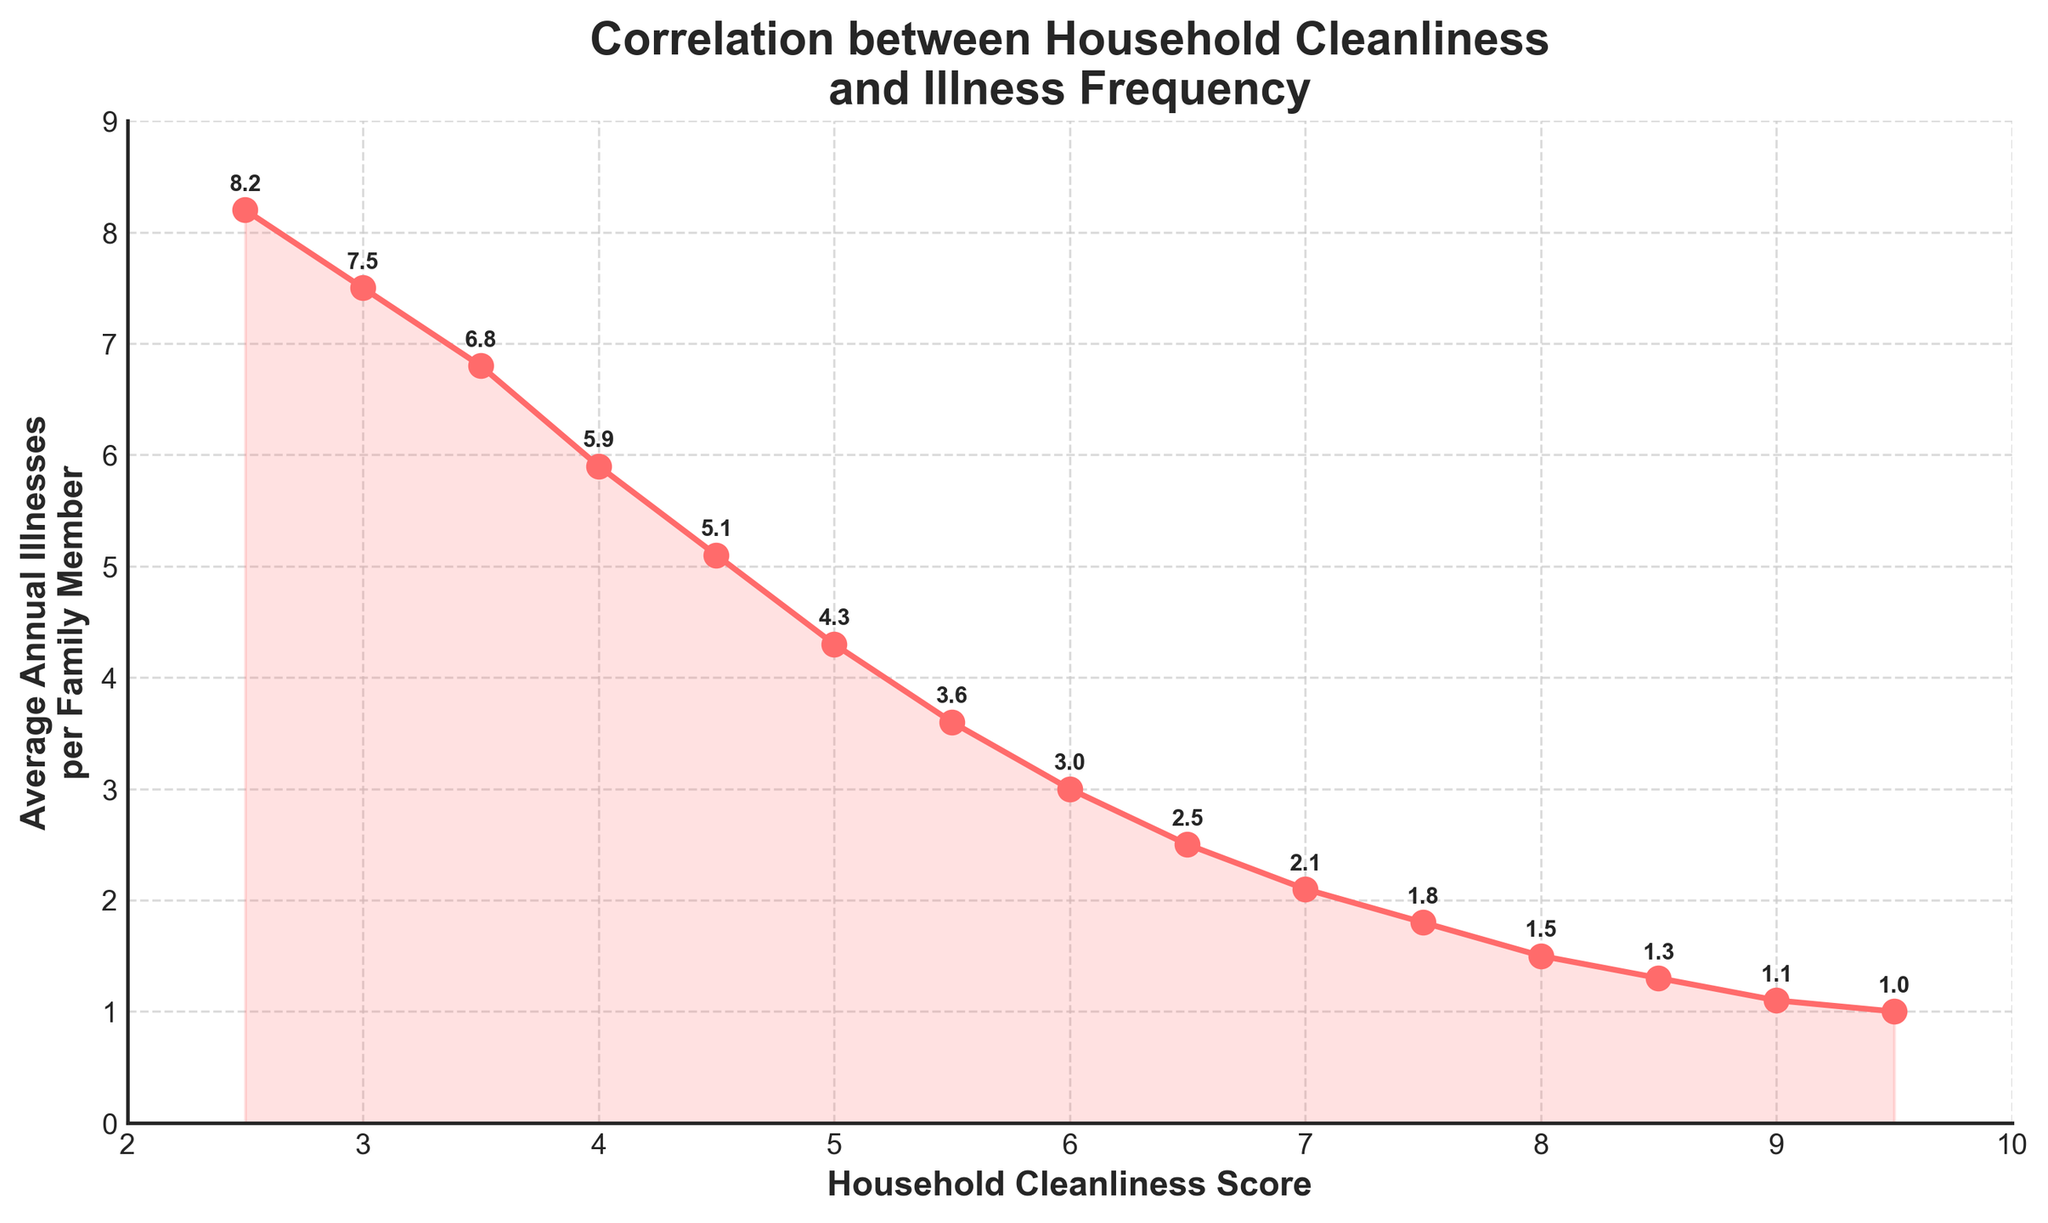What is the average Annual Illnesses per Family Member for a Household Cleanliness Score of 5.0? The figure shows that for a Household Cleanliness Score of 5.0, the corresponding value on the y-axis is 4.3. Therefore, the average annual illnesses per family member for a cleanliness score of 5.0 is 4.3
Answer: 4.3 Does a higher Household Cleanliness Score correlate with fewer Average Annual Illnesses per Family Member? Visually inspecting the plot, as the Household Cleanliness Score increases from 2.5 to 9.5, the Average Annual Illnesses per Family Member decreases consistently. This shows a negative correlation between the two variables, suggesting that higher cleanliness scores correlate with fewer annual illnesses.
Answer: Yes Compare the Average Annual Illnesses per Family Member for Household Cleanliness Scores of 3.5 and 6.0. Which one has a lower illness frequency? For a Household Cleanliness Score of 3.5, the chart shows an average annual illness frequency of 6.8. For a score of 6.0, the frequency is 3.0. Comparing these values shows that a score of 6.0 has a significantly lower illness frequency than a score of 3.5.
Answer: 6.0 What trend do you observe as the Household Cleanliness Score increases from 2.5 to 9.5? The plot reveals a decreasing trend in Average Annual Illnesses per Family Member as the Household Cleanliness Score increases. This indicates that families with higher cleanliness scores tend to have fewer annual illnesses.
Answer: Decreasing trend What is the difference in Average Annual Illnesses per Family Member between Household Cleanliness Scores of 4.5 and 7.5? The graph shows that for a score of 4.5, the average annual illnesses per family member is 5.1, and for a score of 7.5, it is 1.8. The difference between these two values is 5.1 - 1.8 = 3.3.
Answer: 3.3 Is there a score where the Average Annual Illnesses per Family Member is close to 1.0? If so, what is the score? The plot shows that a Household Cleanliness Score of 9.5 corresponds to an Average Annual Illnesses per Family Member close to 1.0. Therefore, the score is 9.5.
Answer: 9.5 How does the average annual illness frequency change as the Household Cleanliness Score changes from 5.0 to 10? From the plot, as the cleanliness score increases from 5.0 to 9.5 (with scores ending at 9.5), the average annual illness frequency decreases from 4.3 to almost 1.0. The change indicates a decreasing trend in annual illnesses as cleanliness scores increase.
Answer: Decreases What is the average reduction in Annual Illnesses per Family Member when comparing Household Cleanliness Scores between 2.5 and 8.0? Looking at the chart, for a cleanliness score of 2.5, the frequency is 8.2, and for a score of 8.0, it is 1.5. The average reduction is calculated as 8.2 - 1.5 = 6.7.
Answer: 6.7 For a Household Cleanliness Score of 7.0, what is the approximate value for Average Annual Illnesses per Family Member? According to the chart, for a cleanliness score of 7.0, the corresponding value for average annual illnesses per family member is approximately 2.1.
Answer: 2.1 What do the filled areas under the line in the chart represent? The filled areas under the line graphically represent the total amount of Average Annual Illnesses per Family Member for the given Household Cleanliness Scores. They help visualize the magnitude of illnesses across different cleanliness scores more clearly.
Answer: Total amount of illnesses 